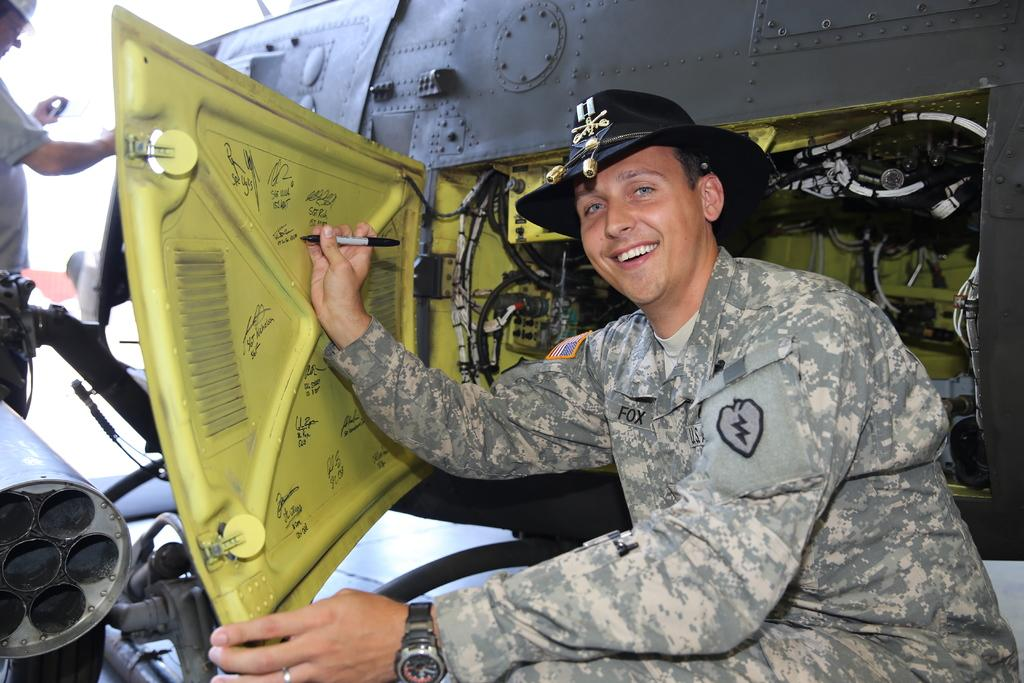What is the person near in the image doing? There is a person sitting near a machine in the image. What is the person holding in his hand? The person is holding a pen in his hand. Can you describe the person's attire? The person is wearing a hat. Are there any other people in the image? Yes, there is another person standing in the image. What direction is the person facing in the image? The provided facts do not mention the direction the person is facing, so it cannot be determined from the image. 